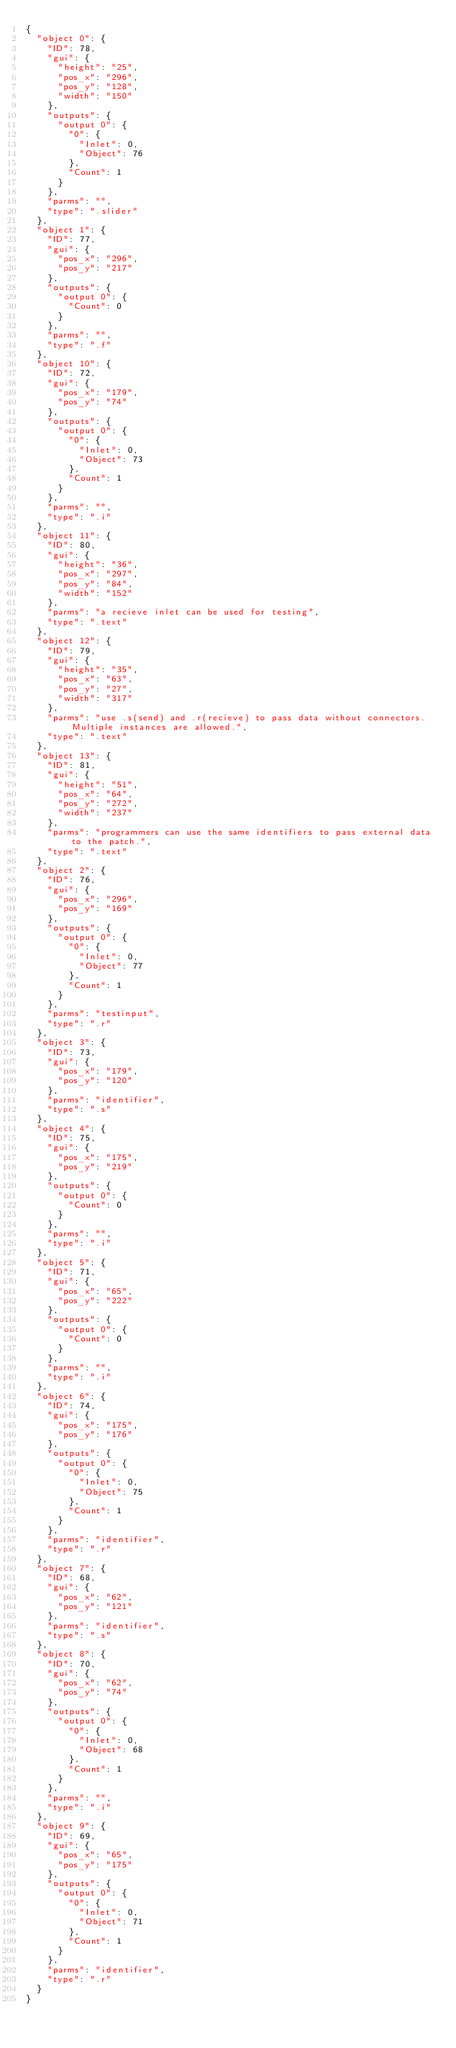Convert code to text. <code><loc_0><loc_0><loc_500><loc_500><_Prolog_>{
  "object 0": {
    "ID": 78,
    "gui": {
      "height": "25",
      "pos_x": "296",
      "pos_y": "128",
      "width": "150"
    },
    "outputs": {
      "output 0": {
        "0": {
          "Inlet": 0,
          "Object": 76
        },
        "Count": 1
      }
    },
    "parms": "",
    "type": ".slider"
  },
  "object 1": {
    "ID": 77,
    "gui": {
      "pos_x": "296",
      "pos_y": "217"
    },
    "outputs": {
      "output 0": {
        "Count": 0
      }
    },
    "parms": "",
    "type": ".f"
  },
  "object 10": {
    "ID": 72,
    "gui": {
      "pos_x": "179",
      "pos_y": "74"
    },
    "outputs": {
      "output 0": {
        "0": {
          "Inlet": 0,
          "Object": 73
        },
        "Count": 1
      }
    },
    "parms": "",
    "type": ".i"
  },
  "object 11": {
    "ID": 80,
    "gui": {
      "height": "36",
      "pos_x": "297",
      "pos_y": "84",
      "width": "152"
    },
    "parms": "a recieve inlet can be used for testing",
    "type": ".text"
  },
  "object 12": {
    "ID": 79,
    "gui": {
      "height": "35",
      "pos_x": "63",
      "pos_y": "27",
      "width": "317"
    },
    "parms": "use .s(send) and .r(recieve) to pass data without connectors. Multiple instances are allowed.",
    "type": ".text"
  },
  "object 13": {
    "ID": 81,
    "gui": {
      "height": "51",
      "pos_x": "64",
      "pos_y": "272",
      "width": "237"
    },
    "parms": "programmers can use the same identifiers to pass external data to the patch.",
    "type": ".text"
  },
  "object 2": {
    "ID": 76,
    "gui": {
      "pos_x": "296",
      "pos_y": "169"
    },
    "outputs": {
      "output 0": {
        "0": {
          "Inlet": 0,
          "Object": 77
        },
        "Count": 1
      }
    },
    "parms": "testinput",
    "type": ".r"
  },
  "object 3": {
    "ID": 73,
    "gui": {
      "pos_x": "179",
      "pos_y": "120"
    },
    "parms": "identifier",
    "type": ".s"
  },
  "object 4": {
    "ID": 75,
    "gui": {
      "pos_x": "175",
      "pos_y": "219"
    },
    "outputs": {
      "output 0": {
        "Count": 0
      }
    },
    "parms": "",
    "type": ".i"
  },
  "object 5": {
    "ID": 71,
    "gui": {
      "pos_x": "65",
      "pos_y": "222"
    },
    "outputs": {
      "output 0": {
        "Count": 0
      }
    },
    "parms": "",
    "type": ".i"
  },
  "object 6": {
    "ID": 74,
    "gui": {
      "pos_x": "175",
      "pos_y": "176"
    },
    "outputs": {
      "output 0": {
        "0": {
          "Inlet": 0,
          "Object": 75
        },
        "Count": 1
      }
    },
    "parms": "identifier",
    "type": ".r"
  },
  "object 7": {
    "ID": 68,
    "gui": {
      "pos_x": "62",
      "pos_y": "121"
    },
    "parms": "identifier",
    "type": ".s"
  },
  "object 8": {
    "ID": 70,
    "gui": {
      "pos_x": "62",
      "pos_y": "74"
    },
    "outputs": {
      "output 0": {
        "0": {
          "Inlet": 0,
          "Object": 68
        },
        "Count": 1
      }
    },
    "parms": "",
    "type": ".i"
  },
  "object 9": {
    "ID": 69,
    "gui": {
      "pos_x": "65",
      "pos_y": "175"
    },
    "outputs": {
      "output 0": {
        "0": {
          "Inlet": 0,
          "Object": 71
        },
        "Count": 1
      }
    },
    "parms": "identifier",
    "type": ".r"
  }
}</code> 